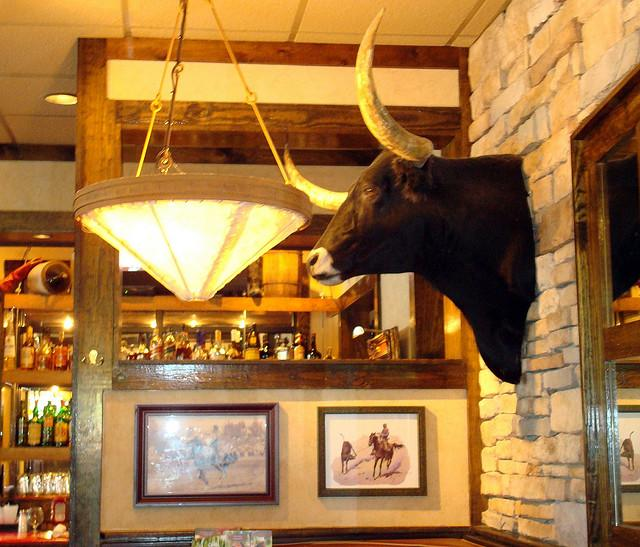What type of facility is displaying the animal head?

Choices:
A) bar
B) medical office
C) hotel
D) home bar 